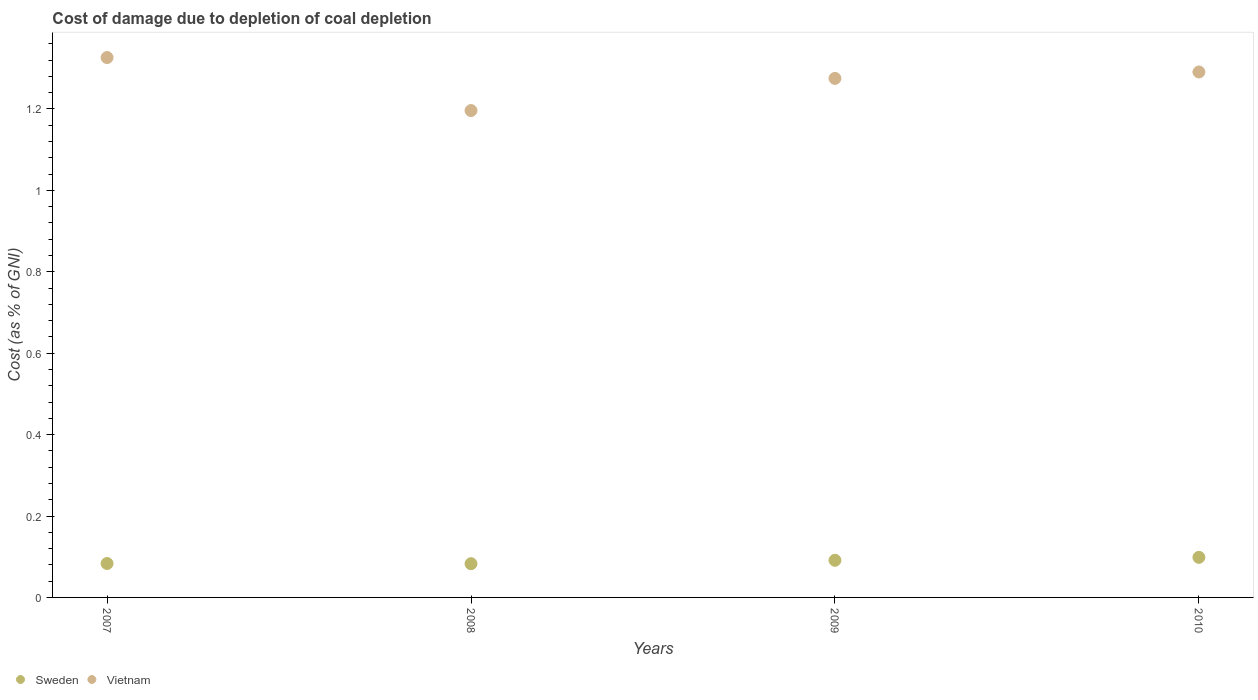How many different coloured dotlines are there?
Your answer should be very brief. 2. Is the number of dotlines equal to the number of legend labels?
Your answer should be very brief. Yes. What is the cost of damage caused due to coal depletion in Sweden in 2010?
Provide a succinct answer. 0.1. Across all years, what is the maximum cost of damage caused due to coal depletion in Vietnam?
Your response must be concise. 1.33. Across all years, what is the minimum cost of damage caused due to coal depletion in Vietnam?
Keep it short and to the point. 1.2. In which year was the cost of damage caused due to coal depletion in Vietnam maximum?
Provide a short and direct response. 2007. What is the total cost of damage caused due to coal depletion in Sweden in the graph?
Make the answer very short. 0.36. What is the difference between the cost of damage caused due to coal depletion in Sweden in 2008 and that in 2010?
Provide a short and direct response. -0.02. What is the difference between the cost of damage caused due to coal depletion in Sweden in 2010 and the cost of damage caused due to coal depletion in Vietnam in 2009?
Offer a very short reply. -1.18. What is the average cost of damage caused due to coal depletion in Vietnam per year?
Your response must be concise. 1.27. In the year 2010, what is the difference between the cost of damage caused due to coal depletion in Vietnam and cost of damage caused due to coal depletion in Sweden?
Offer a very short reply. 1.19. In how many years, is the cost of damage caused due to coal depletion in Sweden greater than 1.2400000000000002 %?
Ensure brevity in your answer.  0. What is the ratio of the cost of damage caused due to coal depletion in Vietnam in 2007 to that in 2009?
Provide a short and direct response. 1.04. Is the cost of damage caused due to coal depletion in Sweden in 2009 less than that in 2010?
Ensure brevity in your answer.  Yes. Is the difference between the cost of damage caused due to coal depletion in Vietnam in 2007 and 2010 greater than the difference between the cost of damage caused due to coal depletion in Sweden in 2007 and 2010?
Give a very brief answer. Yes. What is the difference between the highest and the second highest cost of damage caused due to coal depletion in Sweden?
Your answer should be very brief. 0.01. What is the difference between the highest and the lowest cost of damage caused due to coal depletion in Sweden?
Your response must be concise. 0.02. In how many years, is the cost of damage caused due to coal depletion in Vietnam greater than the average cost of damage caused due to coal depletion in Vietnam taken over all years?
Give a very brief answer. 3. Is the cost of damage caused due to coal depletion in Vietnam strictly greater than the cost of damage caused due to coal depletion in Sweden over the years?
Ensure brevity in your answer.  Yes. Is the cost of damage caused due to coal depletion in Vietnam strictly less than the cost of damage caused due to coal depletion in Sweden over the years?
Offer a very short reply. No. How many dotlines are there?
Your answer should be very brief. 2. How many years are there in the graph?
Your answer should be compact. 4. Are the values on the major ticks of Y-axis written in scientific E-notation?
Your response must be concise. No. Does the graph contain any zero values?
Offer a very short reply. No. Does the graph contain grids?
Ensure brevity in your answer.  No. Where does the legend appear in the graph?
Provide a succinct answer. Bottom left. What is the title of the graph?
Provide a succinct answer. Cost of damage due to depletion of coal depletion. Does "Cuba" appear as one of the legend labels in the graph?
Give a very brief answer. No. What is the label or title of the Y-axis?
Give a very brief answer. Cost (as % of GNI). What is the Cost (as % of GNI) in Sweden in 2007?
Provide a short and direct response. 0.08. What is the Cost (as % of GNI) in Vietnam in 2007?
Give a very brief answer. 1.33. What is the Cost (as % of GNI) of Sweden in 2008?
Give a very brief answer. 0.08. What is the Cost (as % of GNI) of Vietnam in 2008?
Provide a succinct answer. 1.2. What is the Cost (as % of GNI) in Sweden in 2009?
Ensure brevity in your answer.  0.09. What is the Cost (as % of GNI) of Vietnam in 2009?
Your response must be concise. 1.27. What is the Cost (as % of GNI) of Sweden in 2010?
Your response must be concise. 0.1. What is the Cost (as % of GNI) in Vietnam in 2010?
Make the answer very short. 1.29. Across all years, what is the maximum Cost (as % of GNI) in Sweden?
Your answer should be very brief. 0.1. Across all years, what is the maximum Cost (as % of GNI) in Vietnam?
Your response must be concise. 1.33. Across all years, what is the minimum Cost (as % of GNI) in Sweden?
Give a very brief answer. 0.08. Across all years, what is the minimum Cost (as % of GNI) of Vietnam?
Offer a terse response. 1.2. What is the total Cost (as % of GNI) of Sweden in the graph?
Ensure brevity in your answer.  0.36. What is the total Cost (as % of GNI) in Vietnam in the graph?
Your answer should be very brief. 5.09. What is the difference between the Cost (as % of GNI) of Vietnam in 2007 and that in 2008?
Offer a terse response. 0.13. What is the difference between the Cost (as % of GNI) of Sweden in 2007 and that in 2009?
Your answer should be very brief. -0.01. What is the difference between the Cost (as % of GNI) in Vietnam in 2007 and that in 2009?
Provide a succinct answer. 0.05. What is the difference between the Cost (as % of GNI) of Sweden in 2007 and that in 2010?
Your answer should be compact. -0.02. What is the difference between the Cost (as % of GNI) of Vietnam in 2007 and that in 2010?
Keep it short and to the point. 0.04. What is the difference between the Cost (as % of GNI) of Sweden in 2008 and that in 2009?
Keep it short and to the point. -0.01. What is the difference between the Cost (as % of GNI) of Vietnam in 2008 and that in 2009?
Ensure brevity in your answer.  -0.08. What is the difference between the Cost (as % of GNI) in Sweden in 2008 and that in 2010?
Your answer should be compact. -0.02. What is the difference between the Cost (as % of GNI) of Vietnam in 2008 and that in 2010?
Your response must be concise. -0.09. What is the difference between the Cost (as % of GNI) of Sweden in 2009 and that in 2010?
Keep it short and to the point. -0.01. What is the difference between the Cost (as % of GNI) of Vietnam in 2009 and that in 2010?
Ensure brevity in your answer.  -0.02. What is the difference between the Cost (as % of GNI) of Sweden in 2007 and the Cost (as % of GNI) of Vietnam in 2008?
Your answer should be very brief. -1.11. What is the difference between the Cost (as % of GNI) in Sweden in 2007 and the Cost (as % of GNI) in Vietnam in 2009?
Give a very brief answer. -1.19. What is the difference between the Cost (as % of GNI) of Sweden in 2007 and the Cost (as % of GNI) of Vietnam in 2010?
Your response must be concise. -1.21. What is the difference between the Cost (as % of GNI) of Sweden in 2008 and the Cost (as % of GNI) of Vietnam in 2009?
Your response must be concise. -1.19. What is the difference between the Cost (as % of GNI) in Sweden in 2008 and the Cost (as % of GNI) in Vietnam in 2010?
Provide a succinct answer. -1.21. What is the difference between the Cost (as % of GNI) in Sweden in 2009 and the Cost (as % of GNI) in Vietnam in 2010?
Your answer should be compact. -1.2. What is the average Cost (as % of GNI) in Sweden per year?
Your answer should be very brief. 0.09. What is the average Cost (as % of GNI) of Vietnam per year?
Your answer should be compact. 1.27. In the year 2007, what is the difference between the Cost (as % of GNI) in Sweden and Cost (as % of GNI) in Vietnam?
Offer a terse response. -1.24. In the year 2008, what is the difference between the Cost (as % of GNI) of Sweden and Cost (as % of GNI) of Vietnam?
Give a very brief answer. -1.11. In the year 2009, what is the difference between the Cost (as % of GNI) of Sweden and Cost (as % of GNI) of Vietnam?
Your answer should be very brief. -1.18. In the year 2010, what is the difference between the Cost (as % of GNI) of Sweden and Cost (as % of GNI) of Vietnam?
Offer a very short reply. -1.19. What is the ratio of the Cost (as % of GNI) of Vietnam in 2007 to that in 2008?
Offer a very short reply. 1.11. What is the ratio of the Cost (as % of GNI) in Sweden in 2007 to that in 2009?
Offer a terse response. 0.91. What is the ratio of the Cost (as % of GNI) in Vietnam in 2007 to that in 2009?
Your response must be concise. 1.04. What is the ratio of the Cost (as % of GNI) in Sweden in 2007 to that in 2010?
Provide a succinct answer. 0.85. What is the ratio of the Cost (as % of GNI) of Vietnam in 2007 to that in 2010?
Make the answer very short. 1.03. What is the ratio of the Cost (as % of GNI) of Sweden in 2008 to that in 2009?
Offer a very short reply. 0.91. What is the ratio of the Cost (as % of GNI) in Vietnam in 2008 to that in 2009?
Offer a terse response. 0.94. What is the ratio of the Cost (as % of GNI) in Sweden in 2008 to that in 2010?
Ensure brevity in your answer.  0.84. What is the ratio of the Cost (as % of GNI) of Vietnam in 2008 to that in 2010?
Your response must be concise. 0.93. What is the ratio of the Cost (as % of GNI) of Sweden in 2009 to that in 2010?
Keep it short and to the point. 0.93. What is the difference between the highest and the second highest Cost (as % of GNI) in Sweden?
Your answer should be compact. 0.01. What is the difference between the highest and the second highest Cost (as % of GNI) in Vietnam?
Keep it short and to the point. 0.04. What is the difference between the highest and the lowest Cost (as % of GNI) of Sweden?
Your response must be concise. 0.02. What is the difference between the highest and the lowest Cost (as % of GNI) of Vietnam?
Keep it short and to the point. 0.13. 